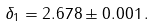<formula> <loc_0><loc_0><loc_500><loc_500>\delta _ { 1 } = 2 . 6 7 8 \pm 0 . 0 0 1 \, .</formula> 